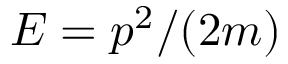<formula> <loc_0><loc_0><loc_500><loc_500>E = p ^ { 2 } / ( 2 m )</formula> 